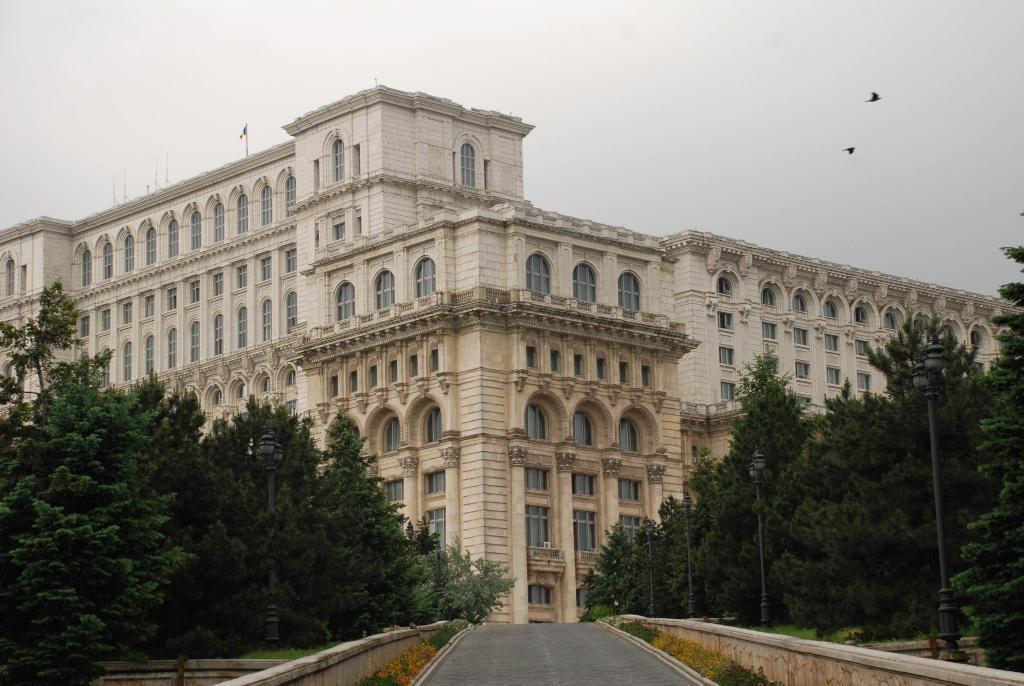In one or two sentences, can you explain what this image depicts? In the foreground I can see a fence, light poles and trees. In the background I can see buildings and windows. On the top I can see the sky and birds. This image is taken during a day. 